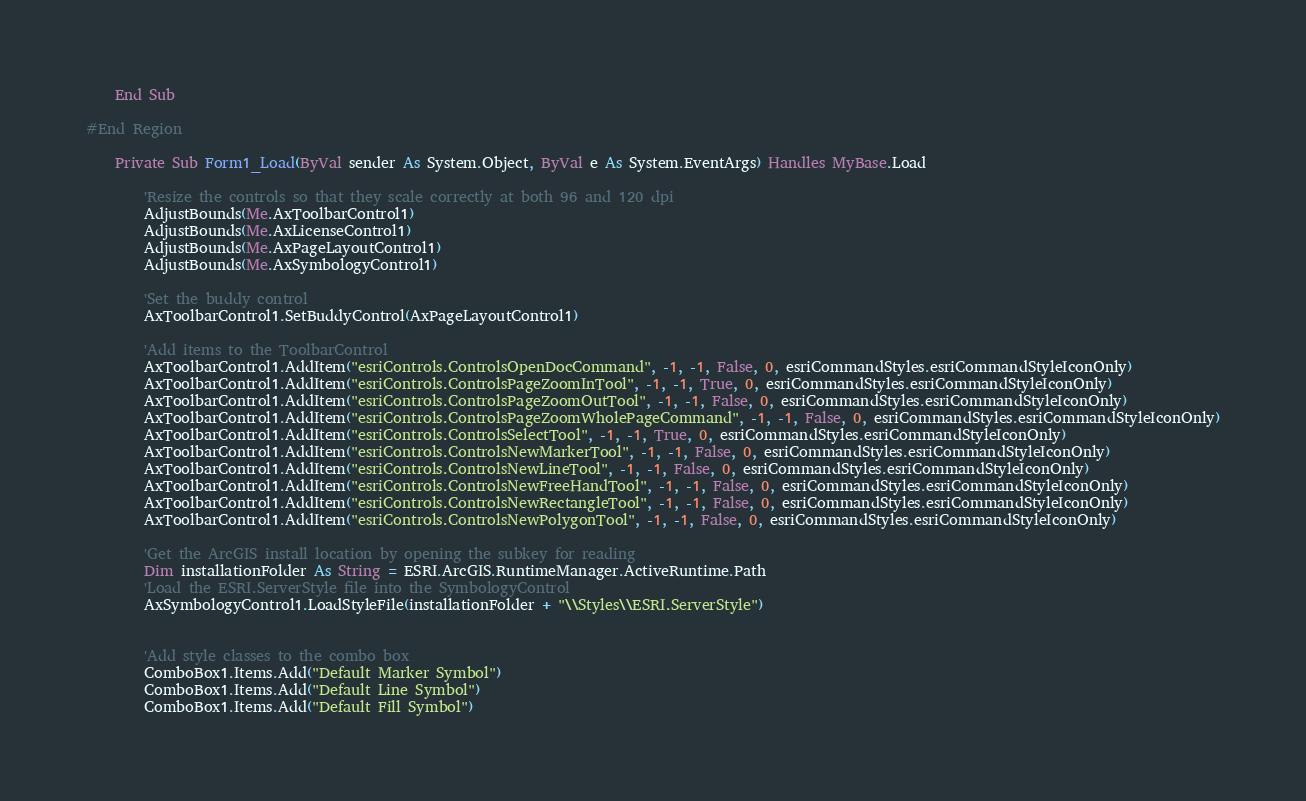Convert code to text. <code><loc_0><loc_0><loc_500><loc_500><_VisualBasic_>
    End Sub

#End Region

    Private Sub Form1_Load(ByVal sender As System.Object, ByVal e As System.EventArgs) Handles MyBase.Load

        'Resize the controls so that they scale correctly at both 96 and 120 dpi
        AdjustBounds(Me.AxToolbarControl1)
        AdjustBounds(Me.AxLicenseControl1)
        AdjustBounds(Me.AxPageLayoutControl1)
        AdjustBounds(Me.AxSymbologyControl1)

        'Set the buddy control
        AxToolbarControl1.SetBuddyControl(AxPageLayoutControl1)

        'Add items to the ToolbarControl
        AxToolbarControl1.AddItem("esriControls.ControlsOpenDocCommand", -1, -1, False, 0, esriCommandStyles.esriCommandStyleIconOnly)
        AxToolbarControl1.AddItem("esriControls.ControlsPageZoomInTool", -1, -1, True, 0, esriCommandStyles.esriCommandStyleIconOnly)
        AxToolbarControl1.AddItem("esriControls.ControlsPageZoomOutTool", -1, -1, False, 0, esriCommandStyles.esriCommandStyleIconOnly)
        AxToolbarControl1.AddItem("esriControls.ControlsPageZoomWholePageCommand", -1, -1, False, 0, esriCommandStyles.esriCommandStyleIconOnly)
        AxToolbarControl1.AddItem("esriControls.ControlsSelectTool", -1, -1, True, 0, esriCommandStyles.esriCommandStyleIconOnly)
        AxToolbarControl1.AddItem("esriControls.ControlsNewMarkerTool", -1, -1, False, 0, esriCommandStyles.esriCommandStyleIconOnly)
        AxToolbarControl1.AddItem("esriControls.ControlsNewLineTool", -1, -1, False, 0, esriCommandStyles.esriCommandStyleIconOnly)
        AxToolbarControl1.AddItem("esriControls.ControlsNewFreeHandTool", -1, -1, False, 0, esriCommandStyles.esriCommandStyleIconOnly)
        AxToolbarControl1.AddItem("esriControls.ControlsNewRectangleTool", -1, -1, False, 0, esriCommandStyles.esriCommandStyleIconOnly)
        AxToolbarControl1.AddItem("esriControls.ControlsNewPolygonTool", -1, -1, False, 0, esriCommandStyles.esriCommandStyleIconOnly)

        'Get the ArcGIS install location by opening the subkey for reading
        Dim installationFolder As String = ESRI.ArcGIS.RuntimeManager.ActiveRuntime.Path
        'Load the ESRI.ServerStyle file into the SymbologyControl
        AxSymbologyControl1.LoadStyleFile(installationFolder + "\\Styles\\ESRI.ServerStyle")


        'Add style classes to the combo box
        ComboBox1.Items.Add("Default Marker Symbol")
        ComboBox1.Items.Add("Default Line Symbol")
        ComboBox1.Items.Add("Default Fill Symbol")</code> 